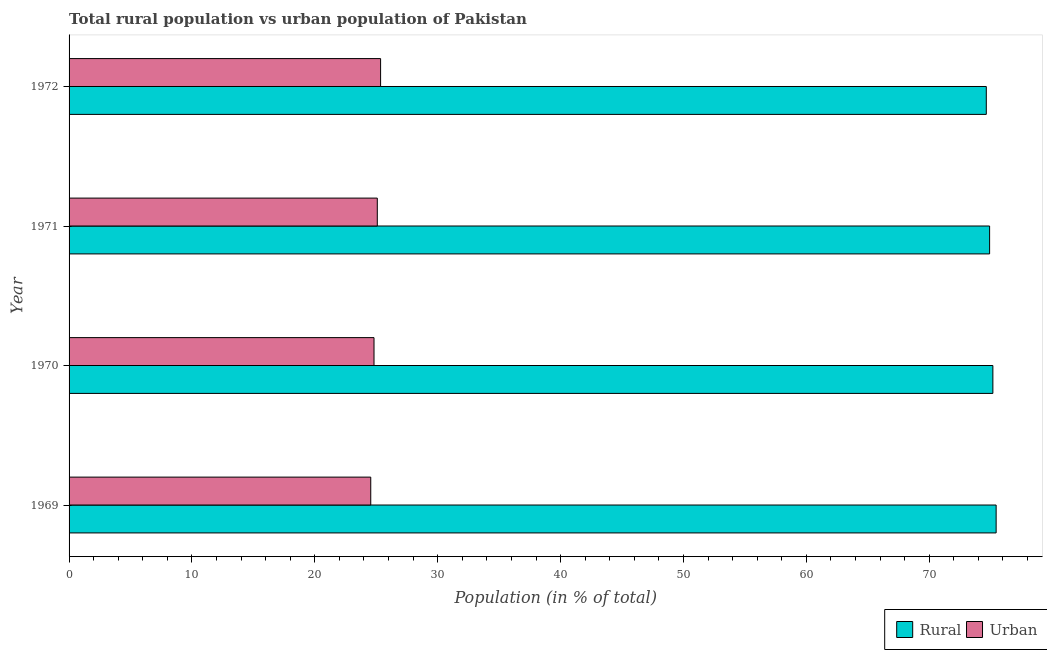How many bars are there on the 3rd tick from the top?
Offer a terse response. 2. How many bars are there on the 2nd tick from the bottom?
Make the answer very short. 2. What is the label of the 4th group of bars from the top?
Offer a terse response. 1969. In how many cases, is the number of bars for a given year not equal to the number of legend labels?
Provide a succinct answer. 0. What is the urban population in 1969?
Offer a very short reply. 24.55. Across all years, what is the maximum rural population?
Offer a very short reply. 75.45. Across all years, what is the minimum rural population?
Offer a terse response. 74.65. In which year was the rural population maximum?
Offer a very short reply. 1969. In which year was the urban population minimum?
Provide a succinct answer. 1969. What is the total rural population in the graph?
Keep it short and to the point. 300.19. What is the difference between the rural population in 1970 and that in 1972?
Offer a terse response. 0.54. What is the difference between the urban population in 1971 and the rural population in 1970?
Make the answer very short. -50.1. What is the average urban population per year?
Provide a short and direct response. 24.95. In the year 1969, what is the difference between the urban population and rural population?
Offer a terse response. -50.9. Is the rural population in 1969 less than that in 1972?
Keep it short and to the point. No. What is the difference between the highest and the second highest rural population?
Provide a short and direct response. 0.27. In how many years, is the urban population greater than the average urban population taken over all years?
Your answer should be compact. 2. What does the 1st bar from the top in 1971 represents?
Your answer should be compact. Urban. What does the 1st bar from the bottom in 1970 represents?
Your answer should be compact. Rural. How many bars are there?
Give a very brief answer. 8. Does the graph contain any zero values?
Ensure brevity in your answer.  No. Does the graph contain grids?
Your response must be concise. No. Where does the legend appear in the graph?
Make the answer very short. Bottom right. What is the title of the graph?
Your answer should be very brief. Total rural population vs urban population of Pakistan. What is the label or title of the X-axis?
Ensure brevity in your answer.  Population (in % of total). What is the label or title of the Y-axis?
Ensure brevity in your answer.  Year. What is the Population (in % of total) in Rural in 1969?
Offer a terse response. 75.45. What is the Population (in % of total) in Urban in 1969?
Keep it short and to the point. 24.55. What is the Population (in % of total) in Rural in 1970?
Provide a short and direct response. 75.18. What is the Population (in % of total) of Urban in 1970?
Ensure brevity in your answer.  24.82. What is the Population (in % of total) in Rural in 1971?
Offer a terse response. 74.92. What is the Population (in % of total) in Urban in 1971?
Your answer should be very brief. 25.08. What is the Population (in % of total) of Rural in 1972?
Your answer should be compact. 74.65. What is the Population (in % of total) of Urban in 1972?
Provide a short and direct response. 25.35. Across all years, what is the maximum Population (in % of total) in Rural?
Your answer should be compact. 75.45. Across all years, what is the maximum Population (in % of total) in Urban?
Your answer should be very brief. 25.35. Across all years, what is the minimum Population (in % of total) of Rural?
Give a very brief answer. 74.65. Across all years, what is the minimum Population (in % of total) of Urban?
Your answer should be compact. 24.55. What is the total Population (in % of total) of Rural in the graph?
Keep it short and to the point. 300.19. What is the total Population (in % of total) of Urban in the graph?
Offer a terse response. 99.81. What is the difference between the Population (in % of total) in Rural in 1969 and that in 1970?
Keep it short and to the point. 0.27. What is the difference between the Population (in % of total) of Urban in 1969 and that in 1970?
Provide a short and direct response. -0.27. What is the difference between the Population (in % of total) of Rural in 1969 and that in 1971?
Provide a short and direct response. 0.53. What is the difference between the Population (in % of total) of Urban in 1969 and that in 1971?
Provide a short and direct response. -0.53. What is the difference between the Population (in % of total) in Rural in 1969 and that in 1972?
Offer a very short reply. 0.8. What is the difference between the Population (in % of total) of Urban in 1969 and that in 1972?
Give a very brief answer. -0.8. What is the difference between the Population (in % of total) of Rural in 1970 and that in 1971?
Provide a short and direct response. 0.27. What is the difference between the Population (in % of total) of Urban in 1970 and that in 1971?
Your answer should be compact. -0.27. What is the difference between the Population (in % of total) in Rural in 1970 and that in 1972?
Make the answer very short. 0.54. What is the difference between the Population (in % of total) in Urban in 1970 and that in 1972?
Your answer should be compact. -0.54. What is the difference between the Population (in % of total) in Rural in 1971 and that in 1972?
Ensure brevity in your answer.  0.27. What is the difference between the Population (in % of total) in Urban in 1971 and that in 1972?
Your answer should be very brief. -0.27. What is the difference between the Population (in % of total) in Rural in 1969 and the Population (in % of total) in Urban in 1970?
Give a very brief answer. 50.63. What is the difference between the Population (in % of total) in Rural in 1969 and the Population (in % of total) in Urban in 1971?
Offer a terse response. 50.36. What is the difference between the Population (in % of total) in Rural in 1969 and the Population (in % of total) in Urban in 1972?
Keep it short and to the point. 50.09. What is the difference between the Population (in % of total) in Rural in 1970 and the Population (in % of total) in Urban in 1971?
Give a very brief answer. 50.1. What is the difference between the Population (in % of total) in Rural in 1970 and the Population (in % of total) in Urban in 1972?
Your response must be concise. 49.83. What is the difference between the Population (in % of total) of Rural in 1971 and the Population (in % of total) of Urban in 1972?
Make the answer very short. 49.56. What is the average Population (in % of total) of Rural per year?
Ensure brevity in your answer.  75.05. What is the average Population (in % of total) of Urban per year?
Your answer should be very brief. 24.95. In the year 1969, what is the difference between the Population (in % of total) in Rural and Population (in % of total) in Urban?
Keep it short and to the point. 50.9. In the year 1970, what is the difference between the Population (in % of total) in Rural and Population (in % of total) in Urban?
Offer a very short reply. 50.37. In the year 1971, what is the difference between the Population (in % of total) of Rural and Population (in % of total) of Urban?
Provide a succinct answer. 49.83. In the year 1972, what is the difference between the Population (in % of total) of Rural and Population (in % of total) of Urban?
Keep it short and to the point. 49.29. What is the ratio of the Population (in % of total) in Urban in 1969 to that in 1970?
Make the answer very short. 0.99. What is the ratio of the Population (in % of total) of Rural in 1969 to that in 1971?
Offer a very short reply. 1.01. What is the ratio of the Population (in % of total) in Urban in 1969 to that in 1971?
Keep it short and to the point. 0.98. What is the ratio of the Population (in % of total) of Rural in 1969 to that in 1972?
Keep it short and to the point. 1.01. What is the ratio of the Population (in % of total) of Urban in 1969 to that in 1972?
Your response must be concise. 0.97. What is the ratio of the Population (in % of total) in Urban in 1970 to that in 1971?
Provide a short and direct response. 0.99. What is the ratio of the Population (in % of total) in Rural in 1970 to that in 1972?
Your answer should be very brief. 1.01. What is the ratio of the Population (in % of total) of Urban in 1970 to that in 1972?
Your answer should be very brief. 0.98. What is the difference between the highest and the second highest Population (in % of total) of Rural?
Offer a very short reply. 0.27. What is the difference between the highest and the second highest Population (in % of total) of Urban?
Offer a very short reply. 0.27. What is the difference between the highest and the lowest Population (in % of total) in Rural?
Offer a very short reply. 0.8. What is the difference between the highest and the lowest Population (in % of total) in Urban?
Ensure brevity in your answer.  0.8. 